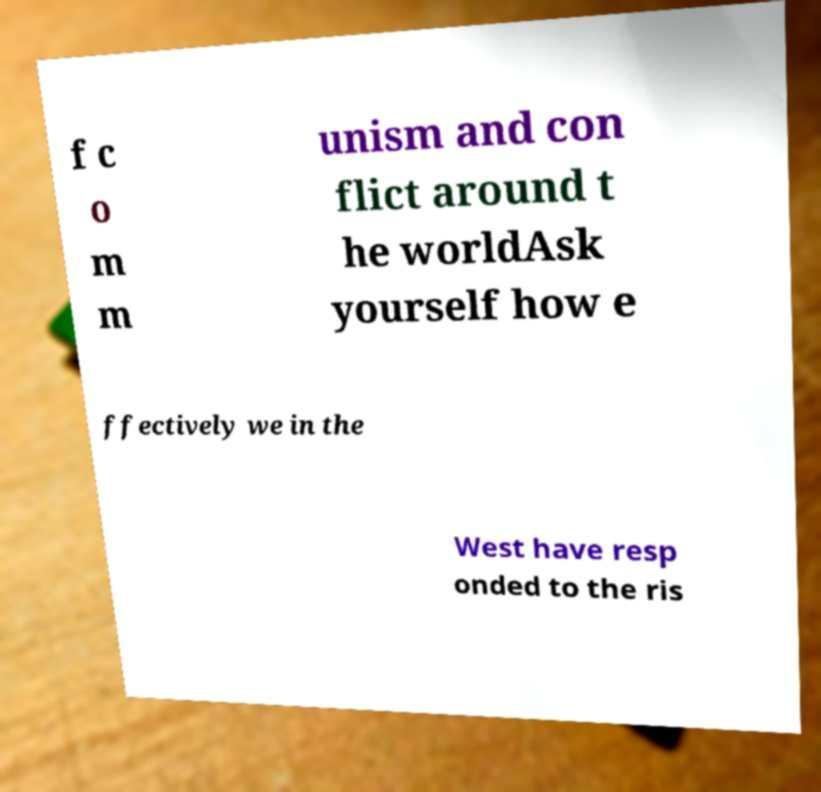Could you assist in decoding the text presented in this image and type it out clearly? f c o m m unism and con flict around t he worldAsk yourself how e ffectively we in the West have resp onded to the ris 